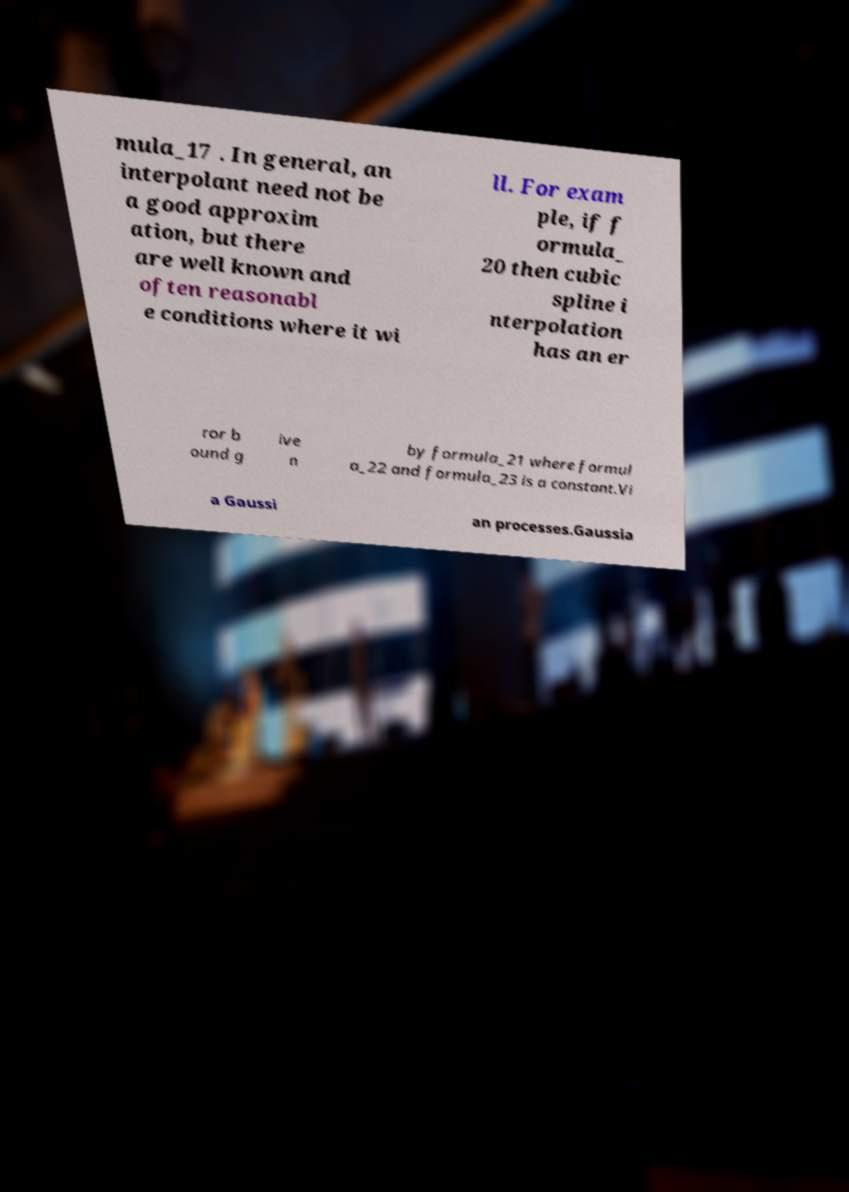Could you extract and type out the text from this image? mula_17 . In general, an interpolant need not be a good approxim ation, but there are well known and often reasonabl e conditions where it wi ll. For exam ple, if f ormula_ 20 then cubic spline i nterpolation has an er ror b ound g ive n by formula_21 where formul a_22 and formula_23 is a constant.Vi a Gaussi an processes.Gaussia 